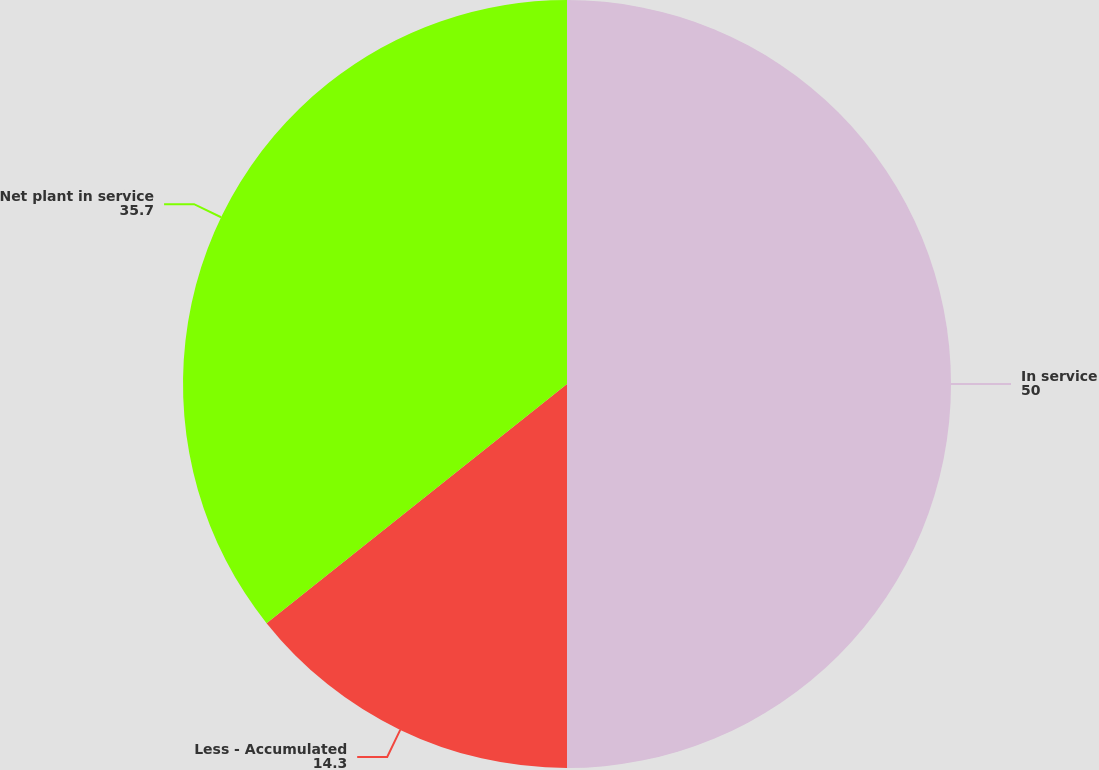<chart> <loc_0><loc_0><loc_500><loc_500><pie_chart><fcel>In service<fcel>Less - Accumulated<fcel>Net plant in service<nl><fcel>50.0%<fcel>14.3%<fcel>35.7%<nl></chart> 